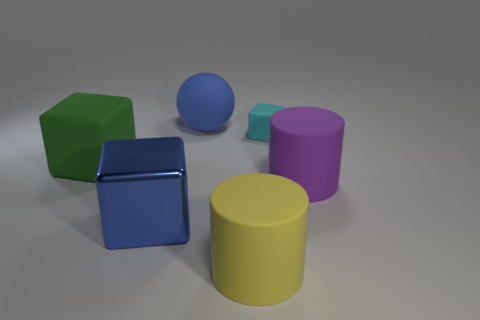What number of yellow cylinders are left of the matte thing that is on the left side of the blue object behind the metal block? Upon reviewing the image, it appears that there are no yellow cylinders to the left of the matte green cube, which is positioned to the left side of the blue sphere behind the metallic cube. 